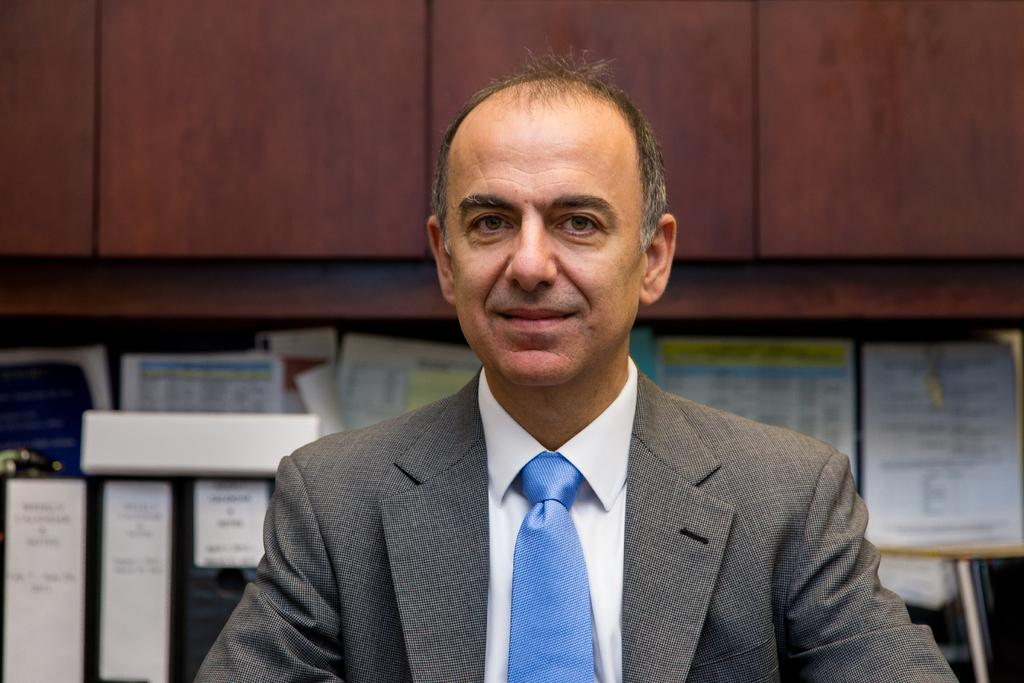Who is the main subject in the image? There is a man in the center of the image. What is the man wearing? The man is wearing a suit and a tie. What can be seen in the background of the image? There are papers and files in the background of the image. What type of furniture is visible at the top of the image? There are cupboards visible at the top of the image. What type of cloud is visible in the image? There is no cloud visible in the image; it appears to be an indoor setting. 